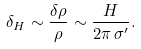<formula> <loc_0><loc_0><loc_500><loc_500>\delta _ { H } \sim \frac { \delta \rho } { \rho } \sim \frac { H } { 2 \pi \, \sigma ^ { \prime } } .</formula> 